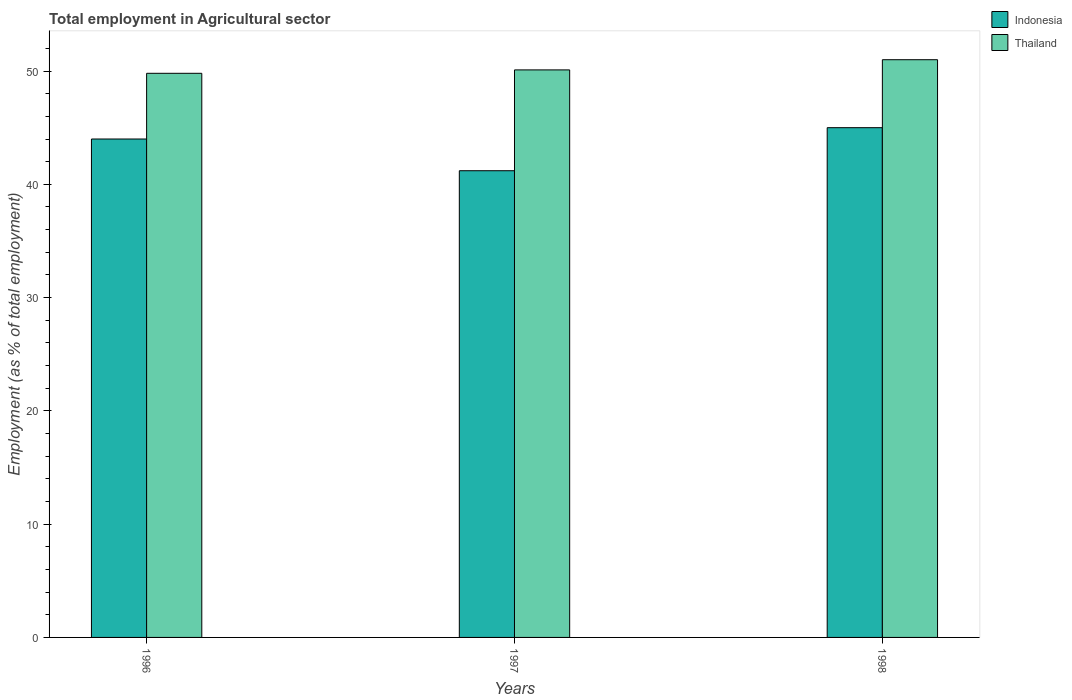How many different coloured bars are there?
Give a very brief answer. 2. Are the number of bars per tick equal to the number of legend labels?
Make the answer very short. Yes. In how many cases, is the number of bars for a given year not equal to the number of legend labels?
Offer a very short reply. 0. What is the employment in agricultural sector in Thailand in 1997?
Offer a very short reply. 50.1. Across all years, what is the maximum employment in agricultural sector in Indonesia?
Provide a short and direct response. 45. Across all years, what is the minimum employment in agricultural sector in Thailand?
Provide a short and direct response. 49.8. In which year was the employment in agricultural sector in Thailand minimum?
Your response must be concise. 1996. What is the total employment in agricultural sector in Thailand in the graph?
Your answer should be very brief. 150.9. What is the difference between the employment in agricultural sector in Thailand in 1996 and that in 1997?
Provide a short and direct response. -0.3. What is the difference between the employment in agricultural sector in Thailand in 1997 and the employment in agricultural sector in Indonesia in 1998?
Provide a short and direct response. 5.1. What is the average employment in agricultural sector in Indonesia per year?
Provide a short and direct response. 43.4. In how many years, is the employment in agricultural sector in Indonesia greater than 16 %?
Give a very brief answer. 3. What is the ratio of the employment in agricultural sector in Indonesia in 1996 to that in 1998?
Offer a terse response. 0.98. Is the difference between the employment in agricultural sector in Indonesia in 1996 and 1998 greater than the difference between the employment in agricultural sector in Thailand in 1996 and 1998?
Your answer should be very brief. Yes. What is the difference between the highest and the lowest employment in agricultural sector in Thailand?
Make the answer very short. 1.2. Is the sum of the employment in agricultural sector in Indonesia in 1997 and 1998 greater than the maximum employment in agricultural sector in Thailand across all years?
Give a very brief answer. Yes. What does the 2nd bar from the left in 1997 represents?
Keep it short and to the point. Thailand. How many bars are there?
Your response must be concise. 6. Are all the bars in the graph horizontal?
Your answer should be compact. No. How many years are there in the graph?
Ensure brevity in your answer.  3. Does the graph contain grids?
Keep it short and to the point. No. What is the title of the graph?
Offer a very short reply. Total employment in Agricultural sector. Does "Bosnia and Herzegovina" appear as one of the legend labels in the graph?
Provide a short and direct response. No. What is the label or title of the X-axis?
Offer a terse response. Years. What is the label or title of the Y-axis?
Offer a terse response. Employment (as % of total employment). What is the Employment (as % of total employment) of Thailand in 1996?
Provide a succinct answer. 49.8. What is the Employment (as % of total employment) of Indonesia in 1997?
Offer a very short reply. 41.2. What is the Employment (as % of total employment) in Thailand in 1997?
Provide a succinct answer. 50.1. Across all years, what is the maximum Employment (as % of total employment) of Thailand?
Offer a very short reply. 51. Across all years, what is the minimum Employment (as % of total employment) in Indonesia?
Keep it short and to the point. 41.2. Across all years, what is the minimum Employment (as % of total employment) of Thailand?
Provide a succinct answer. 49.8. What is the total Employment (as % of total employment) in Indonesia in the graph?
Keep it short and to the point. 130.2. What is the total Employment (as % of total employment) of Thailand in the graph?
Your answer should be very brief. 150.9. What is the difference between the Employment (as % of total employment) in Thailand in 1996 and that in 1997?
Your answer should be compact. -0.3. What is the difference between the Employment (as % of total employment) in Indonesia in 1996 and that in 1998?
Your answer should be compact. -1. What is the difference between the Employment (as % of total employment) in Indonesia in 1996 and the Employment (as % of total employment) in Thailand in 1998?
Ensure brevity in your answer.  -7. What is the average Employment (as % of total employment) of Indonesia per year?
Your response must be concise. 43.4. What is the average Employment (as % of total employment) in Thailand per year?
Offer a very short reply. 50.3. In the year 1997, what is the difference between the Employment (as % of total employment) of Indonesia and Employment (as % of total employment) of Thailand?
Offer a very short reply. -8.9. In the year 1998, what is the difference between the Employment (as % of total employment) in Indonesia and Employment (as % of total employment) in Thailand?
Your response must be concise. -6. What is the ratio of the Employment (as % of total employment) of Indonesia in 1996 to that in 1997?
Make the answer very short. 1.07. What is the ratio of the Employment (as % of total employment) in Thailand in 1996 to that in 1997?
Your response must be concise. 0.99. What is the ratio of the Employment (as % of total employment) of Indonesia in 1996 to that in 1998?
Make the answer very short. 0.98. What is the ratio of the Employment (as % of total employment) of Thailand in 1996 to that in 1998?
Offer a terse response. 0.98. What is the ratio of the Employment (as % of total employment) of Indonesia in 1997 to that in 1998?
Keep it short and to the point. 0.92. What is the ratio of the Employment (as % of total employment) of Thailand in 1997 to that in 1998?
Your answer should be very brief. 0.98. What is the difference between the highest and the second highest Employment (as % of total employment) in Thailand?
Your response must be concise. 0.9. 